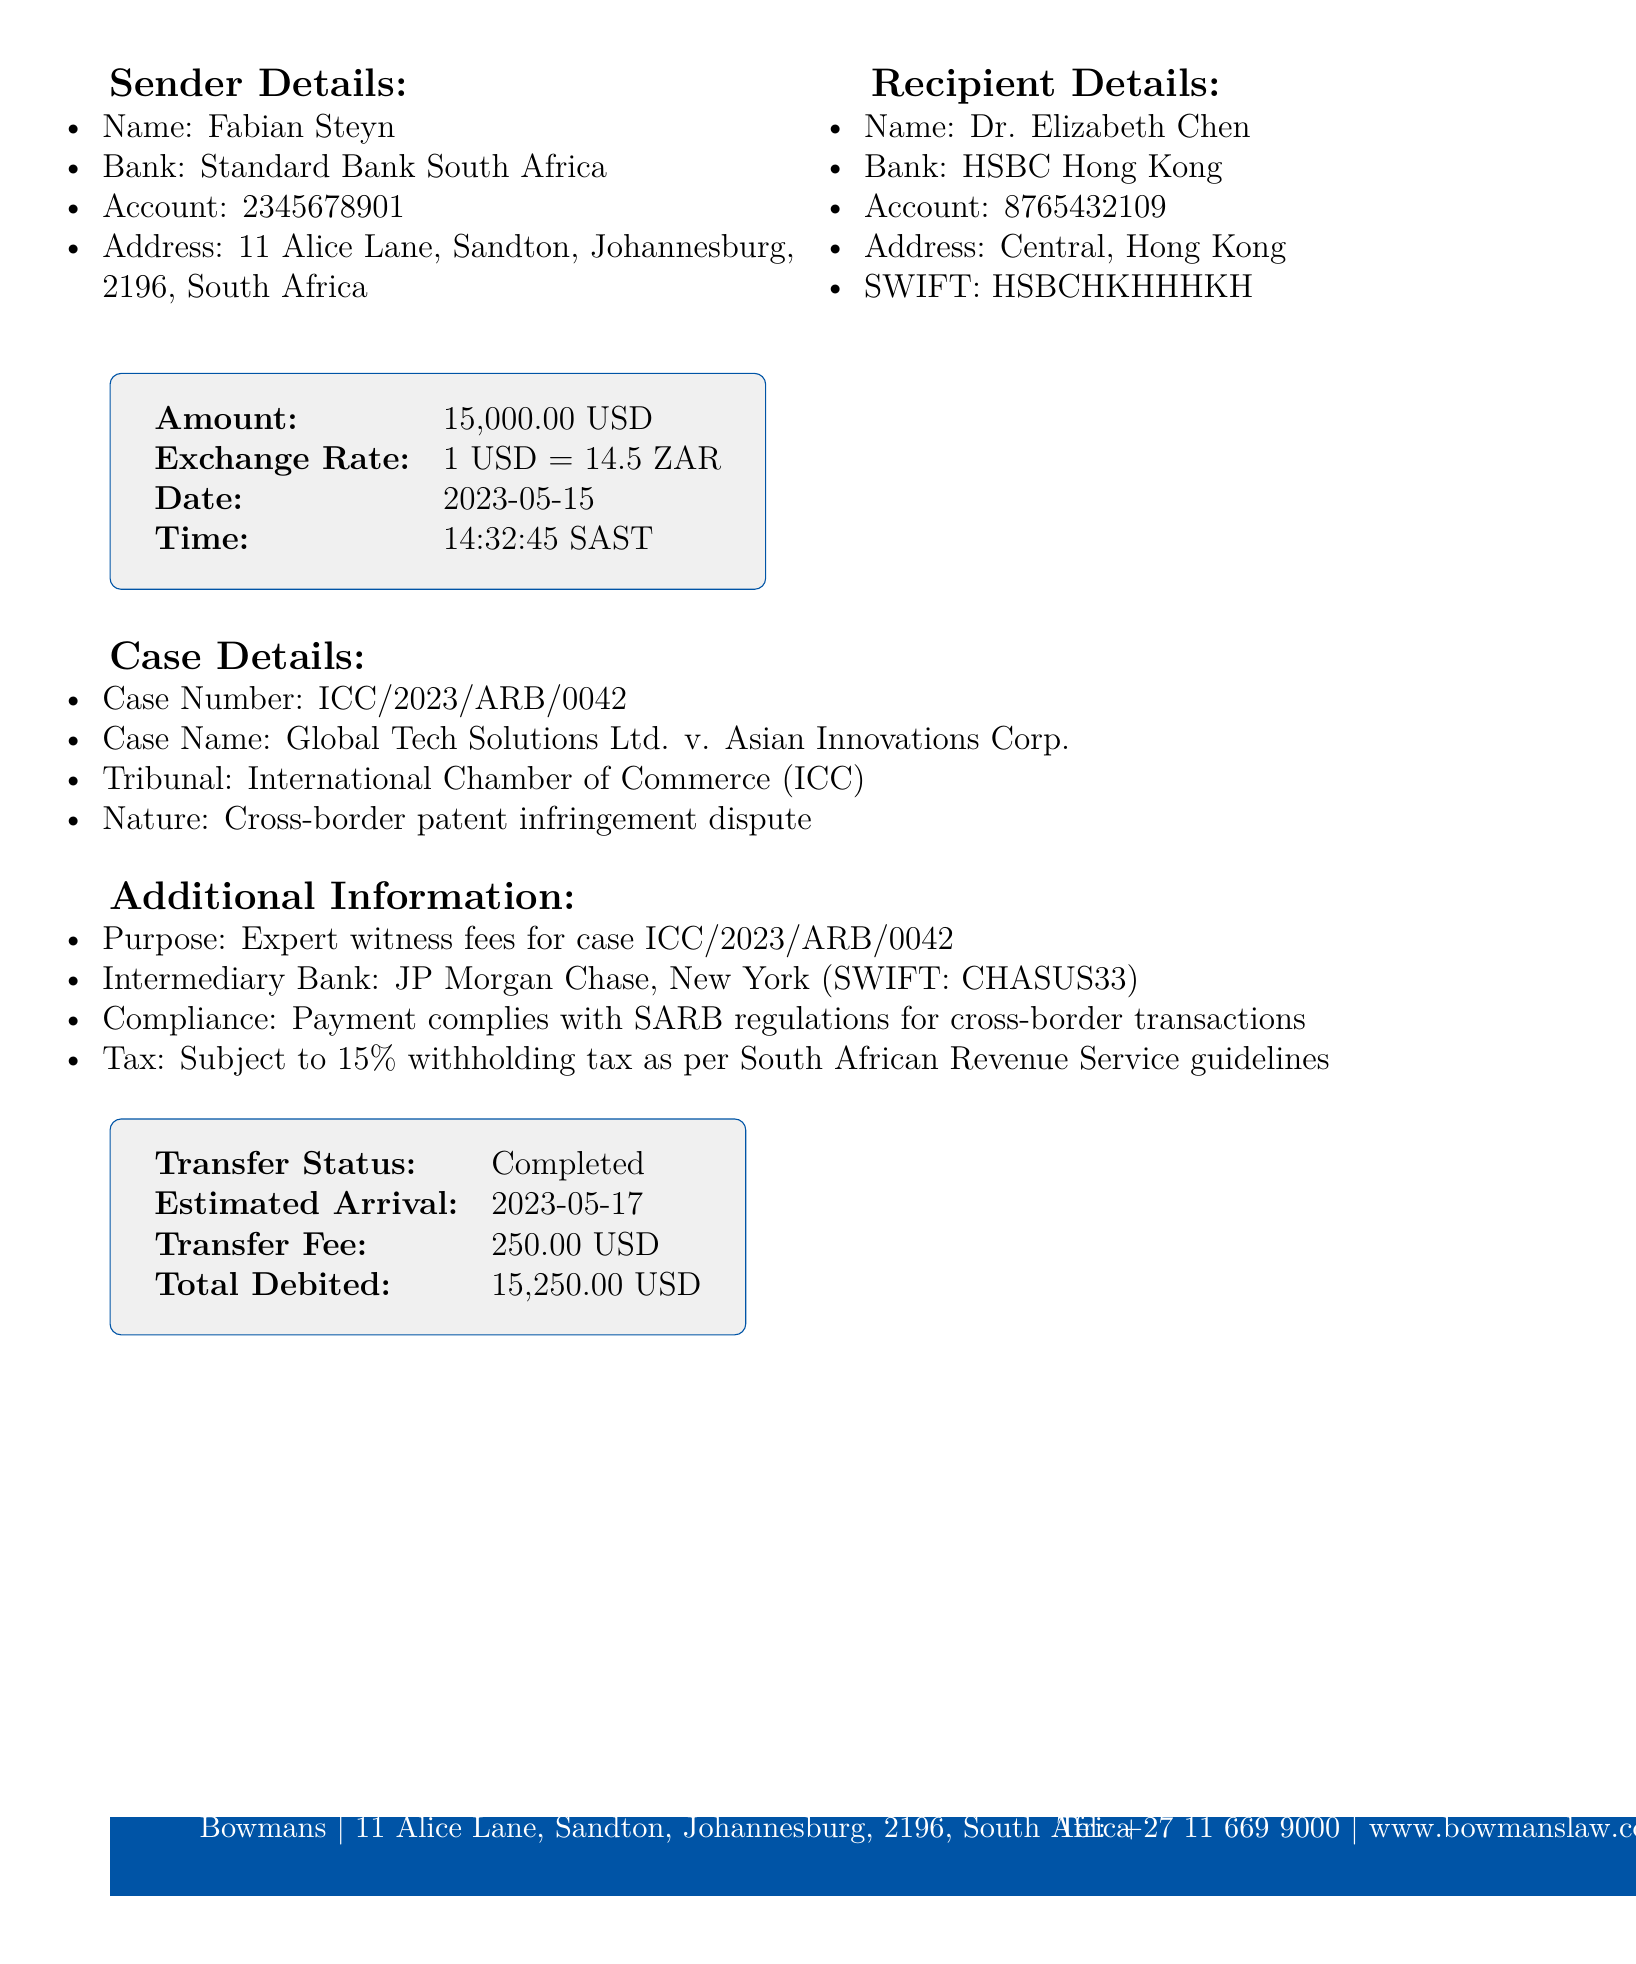what is the sender's name? The sender's name is listed at the beginning of the document under sender details.
Answer: Fabian Steyn what is the recipient's bank? The recipient's bank is mentioned in the recipient details section of the document.
Answer: HSBC Hong Kong what is the amount transferred? The amount transferred is specified in the transaction details section.
Answer: 15,000.00 USD what is the case number? The case number is listed under the case details section of the document.
Answer: ICC/2023/ARB/0042 what is the purpose of the payment? The purpose of the payment is indicated in the additional information section.
Answer: Expert witness fees for case ICC/2023/ARB/0042 how much is the transfer fee? The transfer fee is found in the confirmation details of the document.
Answer: 250.00 USD what will be the estimated arrival date of the transfer? The estimated arrival date is stated in the confirmation details section of the document.
Answer: 2023-05-17 what is the SWIFT code for the recipient's bank? The SWIFT code is specified in the recipient details section alongside the bank information.
Answer: HSBCHKHHHKH what regulatory compliance does the payment adhere to? The compliance information is mentioned in the additional information section regarding regulatory adherence.
Answer: Payment complies with SARB regulations for cross-border transactions 